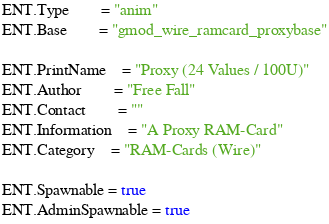<code> <loc_0><loc_0><loc_500><loc_500><_Lua_>ENT.Type 		= "anim"
ENT.Base 		= "gmod_wire_ramcard_proxybase"

ENT.PrintName	= "Proxy (24 Values / 100U)"
ENT.Author		= "Free Fall"
ENT.Contact		= ""
ENT.Information	= "A Proxy RAM-Card"
ENT.Category	= "RAM-Cards (Wire)"

ENT.Spawnable = true
ENT.AdminSpawnable = true
</code> 